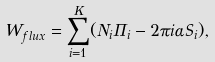Convert formula to latex. <formula><loc_0><loc_0><loc_500><loc_500>W _ { f l u x } = \sum _ { i = 1 } ^ { K } ( N _ { i } \Pi _ { i } - 2 \pi i \alpha S _ { i } ) ,</formula> 